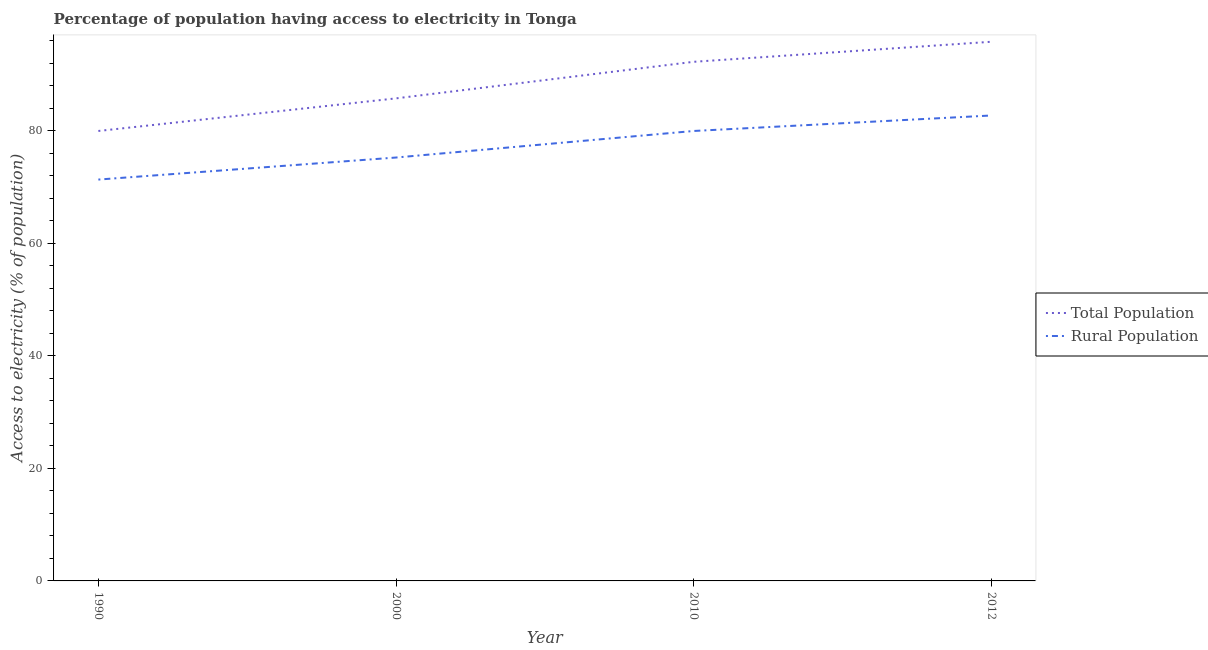Does the line corresponding to percentage of rural population having access to electricity intersect with the line corresponding to percentage of population having access to electricity?
Ensure brevity in your answer.  No. Across all years, what is the maximum percentage of population having access to electricity?
Provide a succinct answer. 95.86. In which year was the percentage of population having access to electricity minimum?
Your answer should be very brief. 1990. What is the total percentage of rural population having access to electricity in the graph?
Your answer should be very brief. 309.4. What is the difference between the percentage of rural population having access to electricity in 2010 and that in 2012?
Your answer should be very brief. -2.75. What is the difference between the percentage of rural population having access to electricity in 1990 and the percentage of population having access to electricity in 2000?
Provide a succinct answer. -14.44. What is the average percentage of rural population having access to electricity per year?
Make the answer very short. 77.35. In the year 2000, what is the difference between the percentage of rural population having access to electricity and percentage of population having access to electricity?
Your answer should be compact. -10.52. In how many years, is the percentage of rural population having access to electricity greater than 32 %?
Your answer should be very brief. 4. What is the ratio of the percentage of population having access to electricity in 1990 to that in 2010?
Offer a terse response. 0.87. What is the difference between the highest and the second highest percentage of rural population having access to electricity?
Ensure brevity in your answer.  2.75. What is the difference between the highest and the lowest percentage of rural population having access to electricity?
Offer a terse response. 11.39. In how many years, is the percentage of population having access to electricity greater than the average percentage of population having access to electricity taken over all years?
Offer a very short reply. 2. Is the sum of the percentage of population having access to electricity in 1990 and 2010 greater than the maximum percentage of rural population having access to electricity across all years?
Provide a succinct answer. Yes. Does the percentage of population having access to electricity monotonically increase over the years?
Make the answer very short. Yes. Is the percentage of rural population having access to electricity strictly greater than the percentage of population having access to electricity over the years?
Offer a terse response. No. How many lines are there?
Your answer should be very brief. 2. How many years are there in the graph?
Offer a terse response. 4. Does the graph contain any zero values?
Your answer should be compact. No. Does the graph contain grids?
Offer a terse response. No. How many legend labels are there?
Your response must be concise. 2. What is the title of the graph?
Your answer should be compact. Percentage of population having access to electricity in Tonga. What is the label or title of the Y-axis?
Keep it short and to the point. Access to electricity (% of population). What is the Access to electricity (% of population) of Rural Population in 1990?
Make the answer very short. 71.36. What is the Access to electricity (% of population) in Total Population in 2000?
Offer a terse response. 85.8. What is the Access to electricity (% of population) in Rural Population in 2000?
Your answer should be compact. 75.28. What is the Access to electricity (% of population) in Total Population in 2010?
Ensure brevity in your answer.  92.3. What is the Access to electricity (% of population) of Rural Population in 2010?
Your answer should be compact. 80. What is the Access to electricity (% of population) of Total Population in 2012?
Your answer should be very brief. 95.86. What is the Access to electricity (% of population) in Rural Population in 2012?
Your answer should be compact. 82.75. Across all years, what is the maximum Access to electricity (% of population) in Total Population?
Offer a terse response. 95.86. Across all years, what is the maximum Access to electricity (% of population) in Rural Population?
Provide a succinct answer. 82.75. Across all years, what is the minimum Access to electricity (% of population) in Total Population?
Keep it short and to the point. 80. Across all years, what is the minimum Access to electricity (% of population) of Rural Population?
Provide a succinct answer. 71.36. What is the total Access to electricity (% of population) of Total Population in the graph?
Give a very brief answer. 353.96. What is the total Access to electricity (% of population) in Rural Population in the graph?
Ensure brevity in your answer.  309.4. What is the difference between the Access to electricity (% of population) of Total Population in 1990 and that in 2000?
Provide a short and direct response. -5.8. What is the difference between the Access to electricity (% of population) of Rural Population in 1990 and that in 2000?
Offer a very short reply. -3.92. What is the difference between the Access to electricity (% of population) of Total Population in 1990 and that in 2010?
Your answer should be compact. -12.3. What is the difference between the Access to electricity (% of population) of Rural Population in 1990 and that in 2010?
Give a very brief answer. -8.64. What is the difference between the Access to electricity (% of population) in Total Population in 1990 and that in 2012?
Make the answer very short. -15.86. What is the difference between the Access to electricity (% of population) in Rural Population in 1990 and that in 2012?
Offer a very short reply. -11.39. What is the difference between the Access to electricity (% of population) of Total Population in 2000 and that in 2010?
Give a very brief answer. -6.5. What is the difference between the Access to electricity (% of population) in Rural Population in 2000 and that in 2010?
Your answer should be compact. -4.72. What is the difference between the Access to electricity (% of population) of Total Population in 2000 and that in 2012?
Offer a very short reply. -10.06. What is the difference between the Access to electricity (% of population) of Rural Population in 2000 and that in 2012?
Provide a short and direct response. -7.47. What is the difference between the Access to electricity (% of population) of Total Population in 2010 and that in 2012?
Provide a short and direct response. -3.56. What is the difference between the Access to electricity (% of population) of Rural Population in 2010 and that in 2012?
Your response must be concise. -2.75. What is the difference between the Access to electricity (% of population) of Total Population in 1990 and the Access to electricity (% of population) of Rural Population in 2000?
Your answer should be very brief. 4.72. What is the difference between the Access to electricity (% of population) of Total Population in 1990 and the Access to electricity (% of population) of Rural Population in 2010?
Make the answer very short. 0. What is the difference between the Access to electricity (% of population) of Total Population in 1990 and the Access to electricity (% of population) of Rural Population in 2012?
Ensure brevity in your answer.  -2.75. What is the difference between the Access to electricity (% of population) of Total Population in 2000 and the Access to electricity (% of population) of Rural Population in 2010?
Provide a short and direct response. 5.8. What is the difference between the Access to electricity (% of population) of Total Population in 2000 and the Access to electricity (% of population) of Rural Population in 2012?
Offer a terse response. 3.04. What is the difference between the Access to electricity (% of population) in Total Population in 2010 and the Access to electricity (% of population) in Rural Population in 2012?
Your response must be concise. 9.55. What is the average Access to electricity (% of population) in Total Population per year?
Offer a very short reply. 88.49. What is the average Access to electricity (% of population) in Rural Population per year?
Give a very brief answer. 77.35. In the year 1990, what is the difference between the Access to electricity (% of population) of Total Population and Access to electricity (% of population) of Rural Population?
Your answer should be compact. 8.64. In the year 2000, what is the difference between the Access to electricity (% of population) of Total Population and Access to electricity (% of population) of Rural Population?
Keep it short and to the point. 10.52. In the year 2012, what is the difference between the Access to electricity (% of population) in Total Population and Access to electricity (% of population) in Rural Population?
Ensure brevity in your answer.  13.11. What is the ratio of the Access to electricity (% of population) of Total Population in 1990 to that in 2000?
Provide a short and direct response. 0.93. What is the ratio of the Access to electricity (% of population) of Rural Population in 1990 to that in 2000?
Offer a terse response. 0.95. What is the ratio of the Access to electricity (% of population) of Total Population in 1990 to that in 2010?
Offer a terse response. 0.87. What is the ratio of the Access to electricity (% of population) in Rural Population in 1990 to that in 2010?
Your answer should be compact. 0.89. What is the ratio of the Access to electricity (% of population) in Total Population in 1990 to that in 2012?
Provide a short and direct response. 0.83. What is the ratio of the Access to electricity (% of population) of Rural Population in 1990 to that in 2012?
Make the answer very short. 0.86. What is the ratio of the Access to electricity (% of population) of Total Population in 2000 to that in 2010?
Provide a succinct answer. 0.93. What is the ratio of the Access to electricity (% of population) in Rural Population in 2000 to that in 2010?
Ensure brevity in your answer.  0.94. What is the ratio of the Access to electricity (% of population) of Total Population in 2000 to that in 2012?
Ensure brevity in your answer.  0.9. What is the ratio of the Access to electricity (% of population) in Rural Population in 2000 to that in 2012?
Your response must be concise. 0.91. What is the ratio of the Access to electricity (% of population) in Total Population in 2010 to that in 2012?
Ensure brevity in your answer.  0.96. What is the ratio of the Access to electricity (% of population) of Rural Population in 2010 to that in 2012?
Provide a succinct answer. 0.97. What is the difference between the highest and the second highest Access to electricity (% of population) of Total Population?
Your answer should be very brief. 3.56. What is the difference between the highest and the second highest Access to electricity (% of population) in Rural Population?
Provide a succinct answer. 2.75. What is the difference between the highest and the lowest Access to electricity (% of population) of Total Population?
Provide a succinct answer. 15.86. What is the difference between the highest and the lowest Access to electricity (% of population) of Rural Population?
Provide a succinct answer. 11.39. 